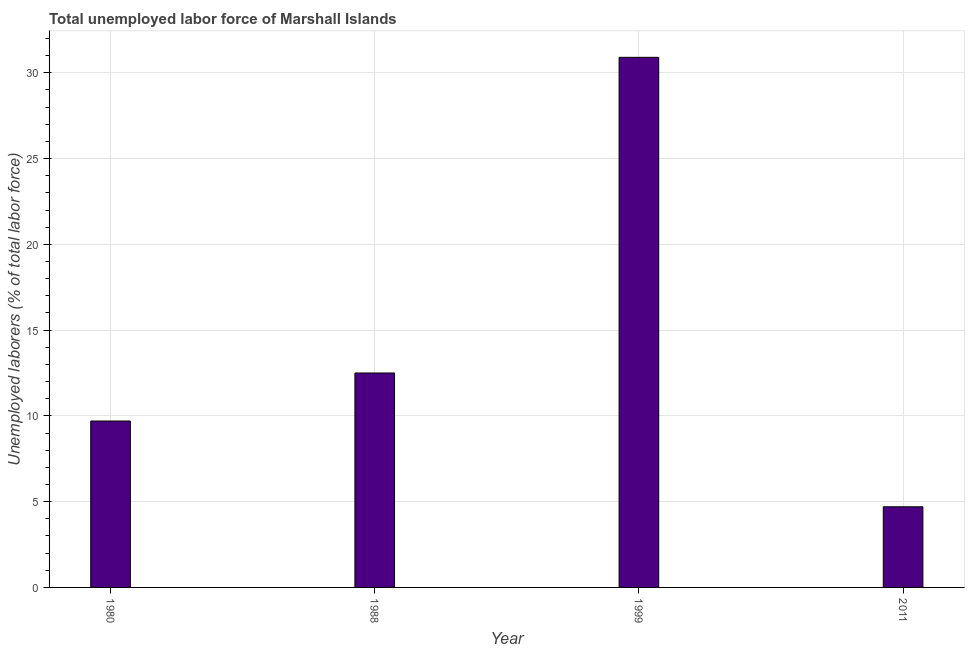Does the graph contain grids?
Provide a succinct answer. Yes. What is the title of the graph?
Your response must be concise. Total unemployed labor force of Marshall Islands. What is the label or title of the X-axis?
Ensure brevity in your answer.  Year. What is the label or title of the Y-axis?
Give a very brief answer. Unemployed laborers (% of total labor force). What is the total unemployed labour force in 1999?
Provide a short and direct response. 30.9. Across all years, what is the maximum total unemployed labour force?
Keep it short and to the point. 30.9. Across all years, what is the minimum total unemployed labour force?
Provide a short and direct response. 4.7. In which year was the total unemployed labour force maximum?
Make the answer very short. 1999. What is the sum of the total unemployed labour force?
Ensure brevity in your answer.  57.8. What is the average total unemployed labour force per year?
Give a very brief answer. 14.45. What is the median total unemployed labour force?
Provide a short and direct response. 11.1. In how many years, is the total unemployed labour force greater than 23 %?
Give a very brief answer. 1. Do a majority of the years between 1999 and 2011 (inclusive) have total unemployed labour force greater than 29 %?
Offer a very short reply. No. What is the ratio of the total unemployed labour force in 1980 to that in 1988?
Your response must be concise. 0.78. Is the total unemployed labour force in 1999 less than that in 2011?
Make the answer very short. No. What is the difference between the highest and the second highest total unemployed labour force?
Your answer should be compact. 18.4. Is the sum of the total unemployed labour force in 1980 and 1988 greater than the maximum total unemployed labour force across all years?
Offer a very short reply. No. What is the difference between the highest and the lowest total unemployed labour force?
Make the answer very short. 26.2. How many bars are there?
Keep it short and to the point. 4. Are all the bars in the graph horizontal?
Your answer should be very brief. No. What is the Unemployed laborers (% of total labor force) in 1980?
Your answer should be compact. 9.7. What is the Unemployed laborers (% of total labor force) of 1999?
Offer a terse response. 30.9. What is the Unemployed laborers (% of total labor force) of 2011?
Provide a short and direct response. 4.7. What is the difference between the Unemployed laborers (% of total labor force) in 1980 and 1999?
Keep it short and to the point. -21.2. What is the difference between the Unemployed laborers (% of total labor force) in 1988 and 1999?
Offer a terse response. -18.4. What is the difference between the Unemployed laborers (% of total labor force) in 1999 and 2011?
Your answer should be very brief. 26.2. What is the ratio of the Unemployed laborers (% of total labor force) in 1980 to that in 1988?
Offer a terse response. 0.78. What is the ratio of the Unemployed laborers (% of total labor force) in 1980 to that in 1999?
Offer a terse response. 0.31. What is the ratio of the Unemployed laborers (% of total labor force) in 1980 to that in 2011?
Your answer should be very brief. 2.06. What is the ratio of the Unemployed laborers (% of total labor force) in 1988 to that in 1999?
Your answer should be compact. 0.41. What is the ratio of the Unemployed laborers (% of total labor force) in 1988 to that in 2011?
Your answer should be very brief. 2.66. What is the ratio of the Unemployed laborers (% of total labor force) in 1999 to that in 2011?
Your answer should be very brief. 6.57. 